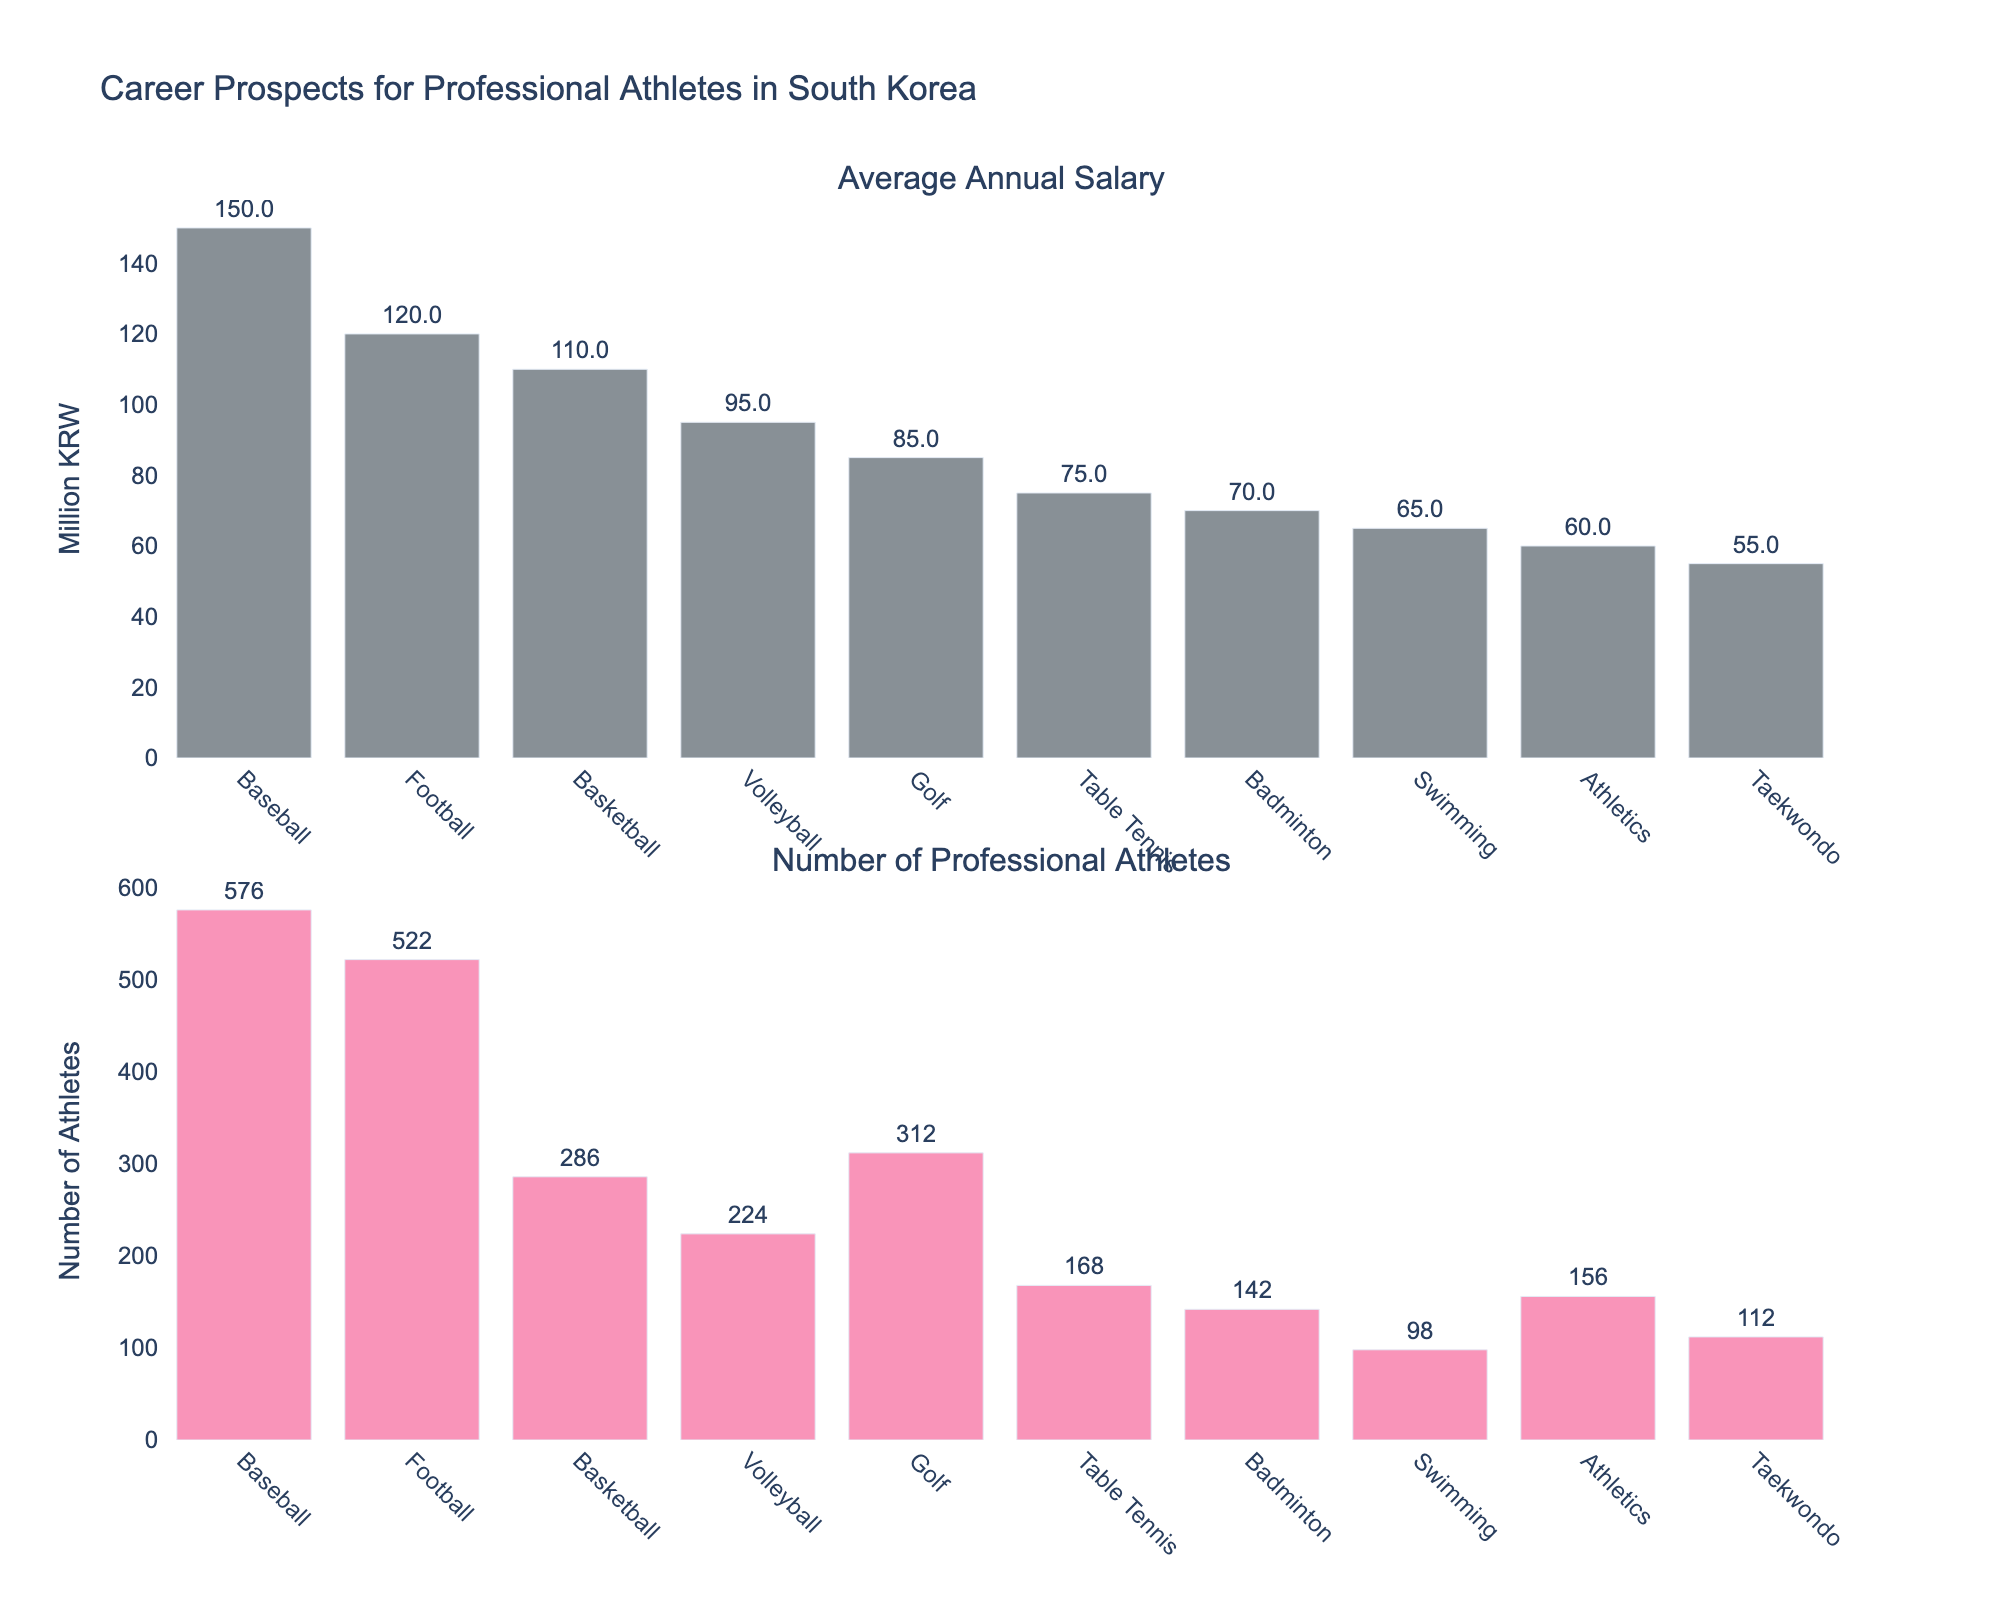What's the sport with the highest average annual salary? The bar chart shows the average annual salary for each sport. By looking at the heights of the bars in the "Average Annual Salary" subplot, the bar for Baseball is the highest indicating it has the highest average annual salary.
Answer: Baseball Which sport has the highest number of professional athletes? In the "Number of Professional Athletes" subplot, you can compare the heights of the bars. The bar for Baseball is the highest, which means it has the highest number of professional athletes.
Answer: Baseball What is the difference in the number of professional athletes between Football and Basketball? First, find the heights of the bars for Football and Basketball in the "Number of Professional Athletes" subplot. Football has 522 athletes, and Basketball has 286. Subtract 286 from 522 to get the difference.
Answer: 236 Which sport has the lowest average annual salary? By looking at the "Average Annual Salary" subplot, the bar for Taekwondo is the shortest, meaning it has the lowest average annual salary.
Answer: Taekwondo What is the total number of professional athletes across all sports? To find the total, add the number of professional athletes in each sport: 576 + 522 + 286 + 224 + 312 + 168 + 142 + 98 + 156 + 112 = 2596.
Answer: 2596 How does the number of professional Golf athletes compare with those in Swimming? Compare the heights of the bars for Golf and Swimming in the "Number of Professional Athletes" subplot. Golf has 312 athletes, while Swimming has 98. Therefore, Golf has more athletes.
Answer: Golf has more athletes What is the average career length across all sports? Calculate the average by summing up the average career lengths for all sports and dividing by the number of sports. (10.5 + 8.2 + 7.8 + 9.3 + 15.6 + 12.4 + 11.8 + 8.7 + 9.5 + 10.2) / 10 = 10.4 years.
Answer: 10.4 years Which sport has more professional athletes: Athletics or Volleyball? Compare the heights of the bars for Athletics and Volleyball in the "Number of Professional Athletes" subplot. Volleyball has 224 athletes, while Athletics has 156. Volleyball has more athletes.
Answer: Volleyball What are the combined average annual salaries for Baseball and Football? Find the average annual salaries for Baseball (150 million KRW) and Football (120 million KRW), and then sum them up: 150 + 120 = 270 million KRW.
Answer: 270 million KRW Which sport has the highest average career length? By comparing the heights of the bars in the "Average Career Length" subplot, Golf has the highest average career length at 15.6 years.
Answer: Golf 